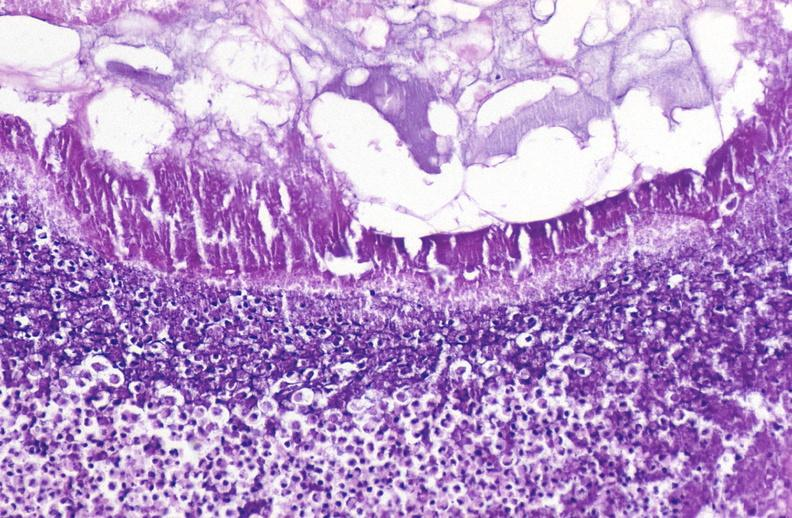does pus in test tube show pancreatic fat necrosis?
Answer the question using a single word or phrase. No 